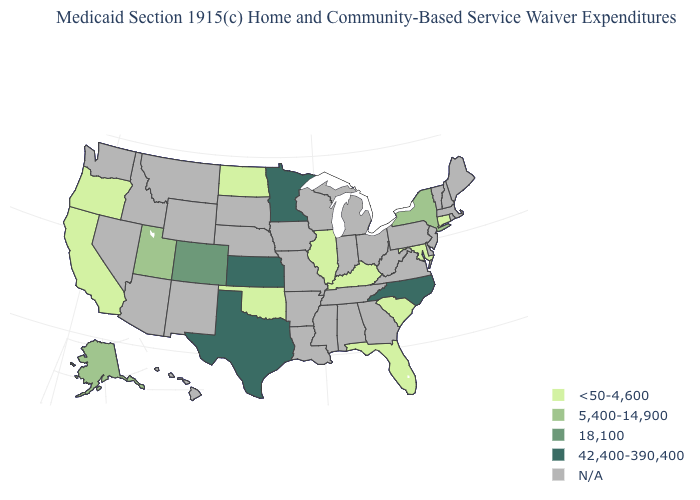What is the lowest value in the West?
Concise answer only. <50-4,600. Name the states that have a value in the range N/A?
Write a very short answer. Alabama, Arizona, Arkansas, Delaware, Georgia, Hawaii, Idaho, Indiana, Iowa, Louisiana, Maine, Massachusetts, Michigan, Mississippi, Missouri, Montana, Nebraska, Nevada, New Hampshire, New Jersey, New Mexico, Ohio, Pennsylvania, Rhode Island, South Dakota, Tennessee, Vermont, Virginia, Washington, West Virginia, Wisconsin, Wyoming. Is the legend a continuous bar?
Write a very short answer. No. What is the value of Oregon?
Keep it brief. <50-4,600. What is the highest value in states that border Iowa?
Keep it brief. 42,400-390,400. What is the value of Rhode Island?
Be succinct. N/A. What is the value of New Jersey?
Write a very short answer. N/A. What is the value of Virginia?
Concise answer only. N/A. Which states hav the highest value in the Northeast?
Answer briefly. New York. Among the states that border New York , which have the highest value?
Short answer required. Connecticut. What is the value of Massachusetts?
Answer briefly. N/A. What is the highest value in states that border Montana?
Answer briefly. <50-4,600. Among the states that border New York , which have the lowest value?
Give a very brief answer. Connecticut. 